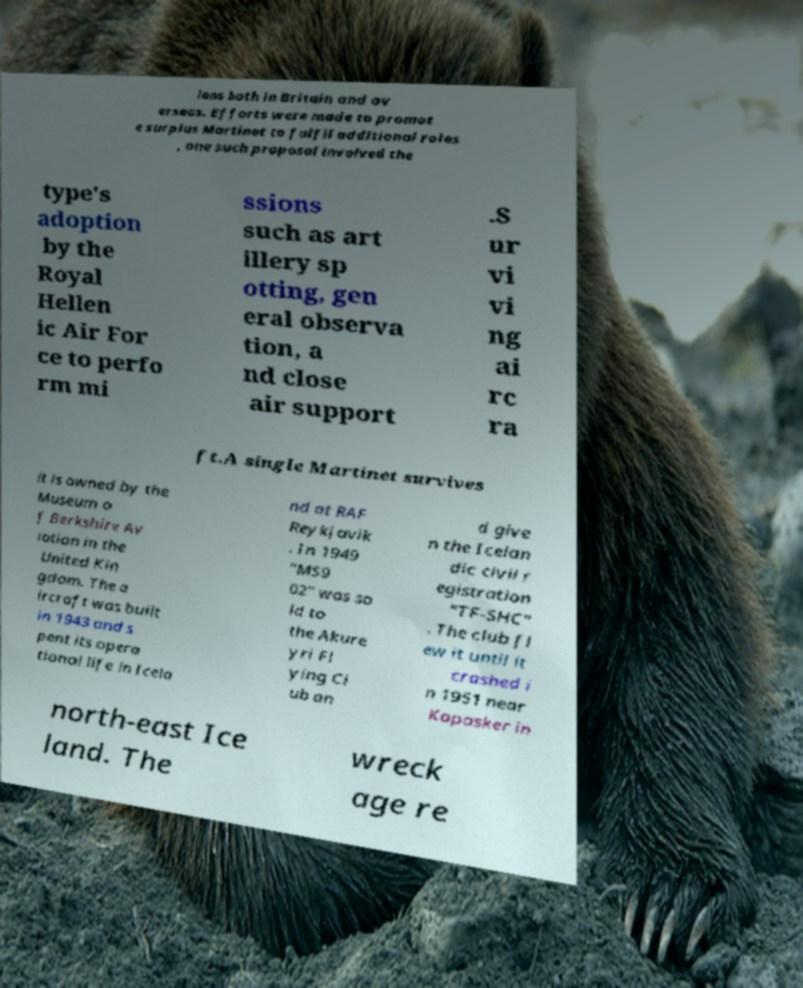Please identify and transcribe the text found in this image. ians both in Britain and ov erseas. Efforts were made to promot e surplus Martinet to fulfil additional roles , one such proposal involved the type's adoption by the Royal Hellen ic Air For ce to perfo rm mi ssions such as art illery sp otting, gen eral observa tion, a nd close air support .S ur vi vi ng ai rc ra ft.A single Martinet survives it is owned by the Museum o f Berkshire Av iation in the United Kin gdom. The a ircraft was built in 1943 and s pent its opera tional life in Icela nd at RAF Reykjavik . In 1949 "MS9 02" was so ld to the Akure yri Fl ying Cl ub an d give n the Icelan dic civil r egistration "TF-SHC" . The club fl ew it until it crashed i n 1951 near Kopasker in north-east Ice land. The wreck age re 